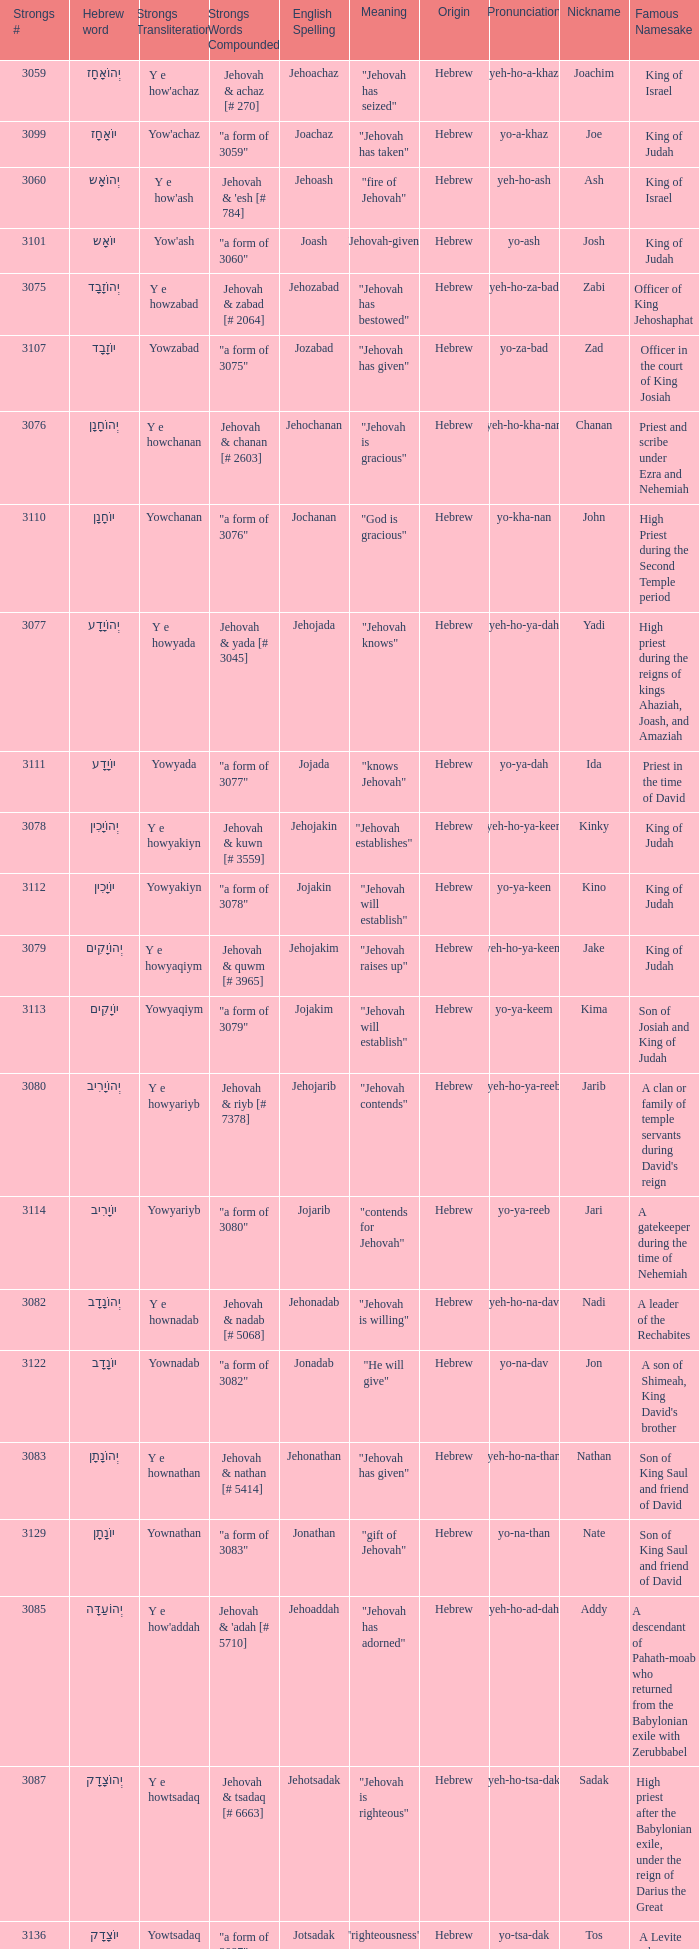What is the strongs # of the english spelling word jehojakin? 3078.0. 